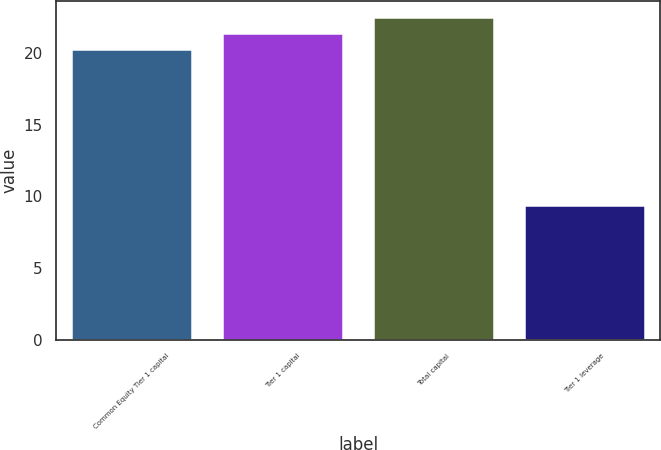<chart> <loc_0><loc_0><loc_500><loc_500><bar_chart><fcel>Common Equity Tier 1 capital<fcel>Tier 1 capital<fcel>Total capital<fcel>Tier 1 leverage<nl><fcel>20.3<fcel>21.4<fcel>22.5<fcel>9.4<nl></chart> 